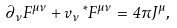<formula> <loc_0><loc_0><loc_500><loc_500>\partial _ { \nu } F ^ { \mu \nu } + v _ { \nu } \, ^ { \ast } F ^ { \mu \nu } = 4 \pi J ^ { \mu } ,</formula> 